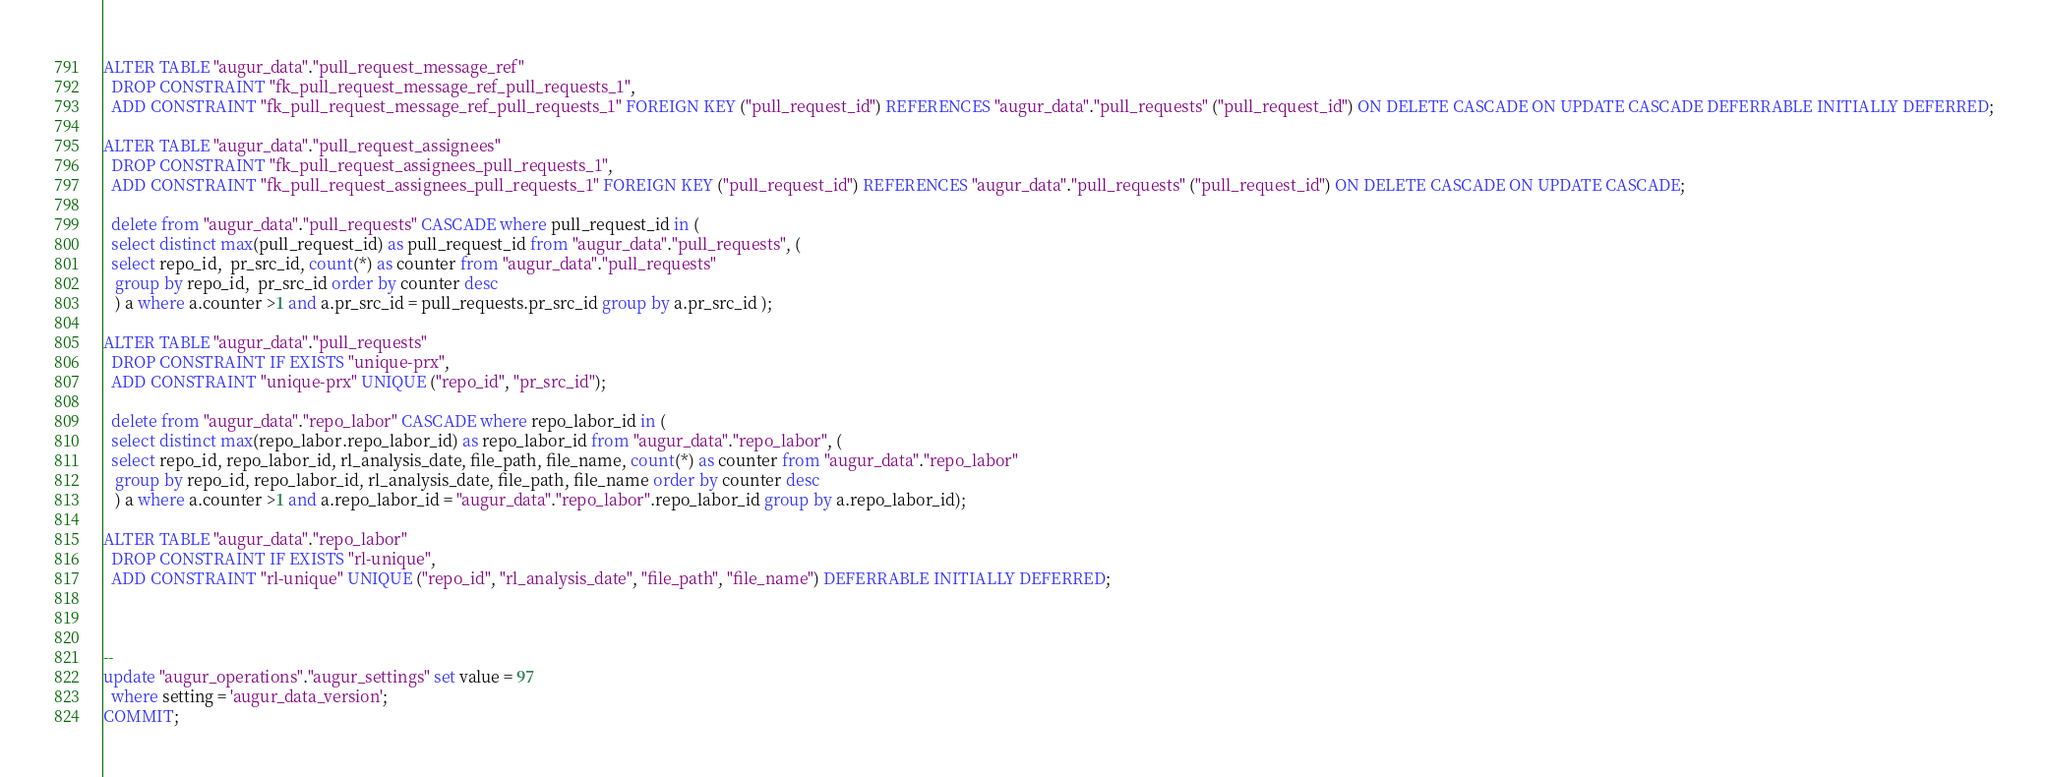Convert code to text. <code><loc_0><loc_0><loc_500><loc_500><_SQL_>
ALTER TABLE "augur_data"."pull_request_message_ref" 
  DROP CONSTRAINT "fk_pull_request_message_ref_pull_requests_1",
  ADD CONSTRAINT "fk_pull_request_message_ref_pull_requests_1" FOREIGN KEY ("pull_request_id") REFERENCES "augur_data"."pull_requests" ("pull_request_id") ON DELETE CASCADE ON UPDATE CASCADE DEFERRABLE INITIALLY DEFERRED;

ALTER TABLE "augur_data"."pull_request_assignees" 
  DROP CONSTRAINT "fk_pull_request_assignees_pull_requests_1",
  ADD CONSTRAINT "fk_pull_request_assignees_pull_requests_1" FOREIGN KEY ("pull_request_id") REFERENCES "augur_data"."pull_requests" ("pull_request_id") ON DELETE CASCADE ON UPDATE CASCADE;

  delete from "augur_data"."pull_requests" CASCADE where pull_request_id in (
  select distinct max(pull_request_id) as pull_request_id from "augur_data"."pull_requests", (
  select repo_id,  pr_src_id, count(*) as counter from "augur_data"."pull_requests"
   group by repo_id,  pr_src_id order by counter desc
   ) a where a.counter >1 and a.pr_src_id = pull_requests.pr_src_id group by a.pr_src_id );
  
ALTER TABLE "augur_data"."pull_requests" 
  DROP CONSTRAINT IF EXISTS "unique-prx",
  ADD CONSTRAINT "unique-prx" UNIQUE ("repo_id", "pr_src_id");

  delete from "augur_data"."repo_labor" CASCADE where repo_labor_id in (
  select distinct max(repo_labor.repo_labor_id) as repo_labor_id from "augur_data"."repo_labor", (
  select repo_id, repo_labor_id, rl_analysis_date, file_path, file_name, count(*) as counter from "augur_data"."repo_labor"
   group by repo_id, repo_labor_id, rl_analysis_date, file_path, file_name order by counter desc
   ) a where a.counter >1 and a.repo_labor_id = "augur_data"."repo_labor".repo_labor_id group by a.repo_labor_id);
   
ALTER TABLE "augur_data"."repo_labor" 
  DROP CONSTRAINT IF EXISTS "rl-unique",
  ADD CONSTRAINT "rl-unique" UNIQUE ("repo_id", "rl_analysis_date", "file_path", "file_name") DEFERRABLE INITIALLY DEFERRED;



--
update "augur_operations"."augur_settings" set value = 97
  where setting = 'augur_data_version'; 
COMMIT; 
</code> 